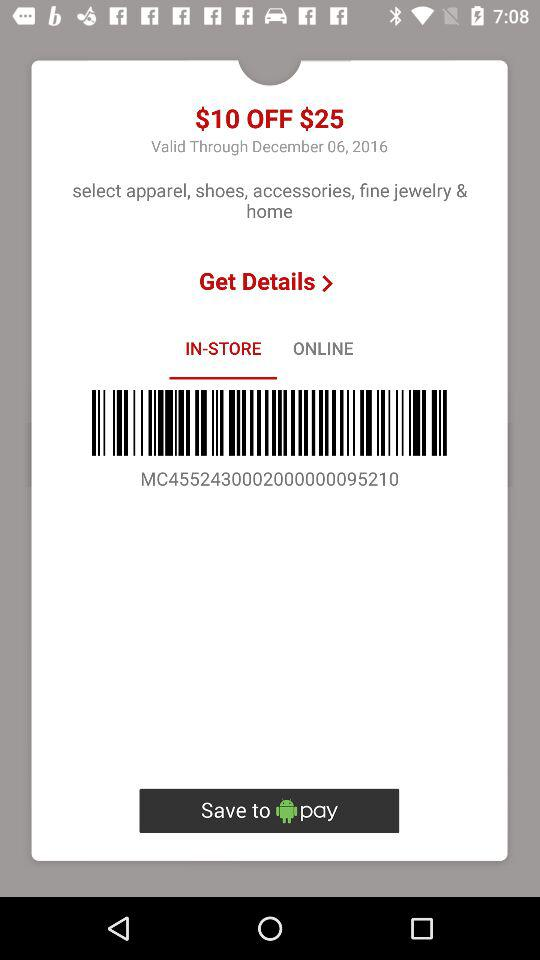How long is the $10 off coupon valid?
Answer the question using a single word or phrase. December 06, 2016 